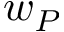<formula> <loc_0><loc_0><loc_500><loc_500>w _ { P }</formula> 